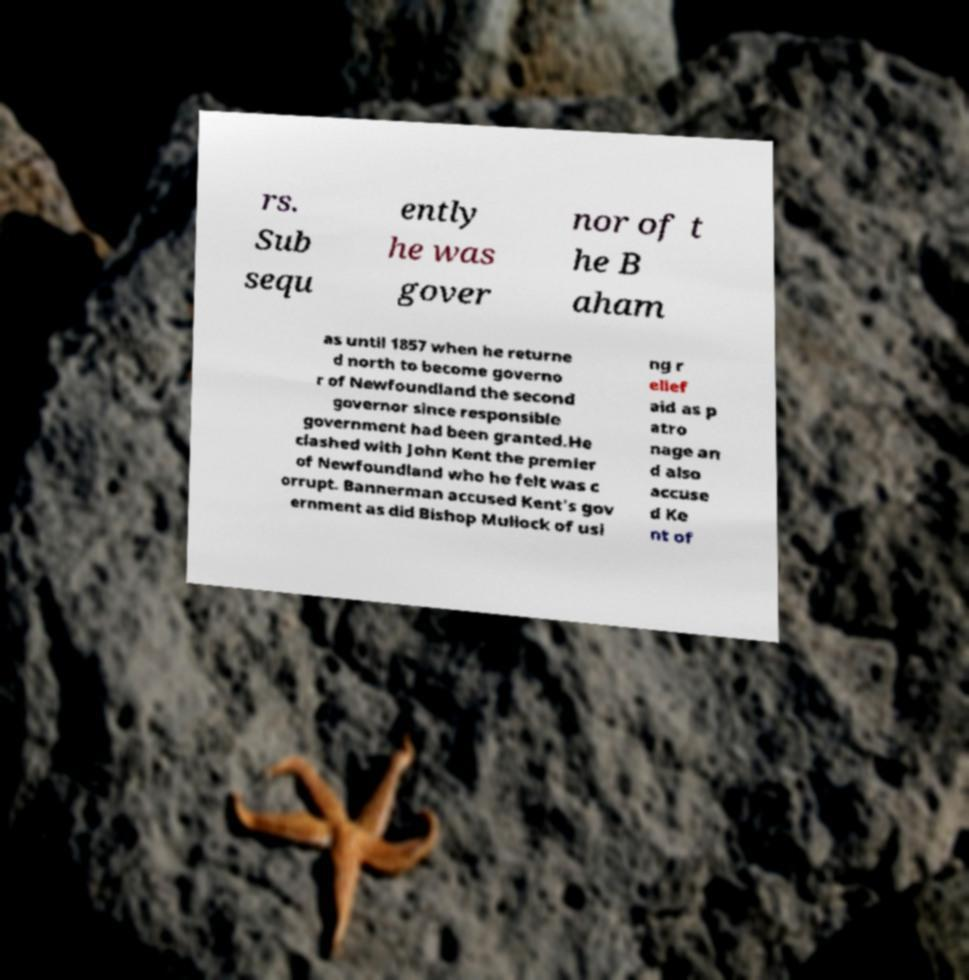For documentation purposes, I need the text within this image transcribed. Could you provide that? rs. Sub sequ ently he was gover nor of t he B aham as until 1857 when he returne d north to become governo r of Newfoundland the second governor since responsible government had been granted.He clashed with John Kent the premier of Newfoundland who he felt was c orrupt. Bannerman accused Kent's gov ernment as did Bishop Mullock of usi ng r elief aid as p atro nage an d also accuse d Ke nt of 